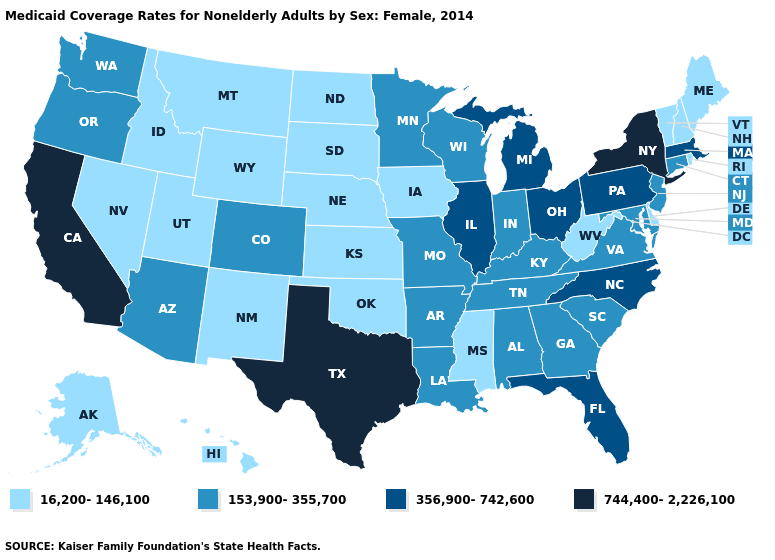What is the value of Texas?
Write a very short answer. 744,400-2,226,100. Among the states that border Maryland , which have the lowest value?
Answer briefly. Delaware, West Virginia. What is the value of Texas?
Concise answer only. 744,400-2,226,100. Does Michigan have the highest value in the MidWest?
Answer briefly. Yes. Does Virginia have the same value as Nevada?
Quick response, please. No. Does the map have missing data?
Concise answer only. No. Does Mississippi have a lower value than Ohio?
Answer briefly. Yes. Name the states that have a value in the range 16,200-146,100?
Be succinct. Alaska, Delaware, Hawaii, Idaho, Iowa, Kansas, Maine, Mississippi, Montana, Nebraska, Nevada, New Hampshire, New Mexico, North Dakota, Oklahoma, Rhode Island, South Dakota, Utah, Vermont, West Virginia, Wyoming. Name the states that have a value in the range 153,900-355,700?
Keep it brief. Alabama, Arizona, Arkansas, Colorado, Connecticut, Georgia, Indiana, Kentucky, Louisiana, Maryland, Minnesota, Missouri, New Jersey, Oregon, South Carolina, Tennessee, Virginia, Washington, Wisconsin. What is the lowest value in the South?
Concise answer only. 16,200-146,100. Does Missouri have the lowest value in the MidWest?
Keep it brief. No. What is the lowest value in the South?
Be succinct. 16,200-146,100. What is the value of Hawaii?
Be succinct. 16,200-146,100. Which states have the lowest value in the Northeast?
Write a very short answer. Maine, New Hampshire, Rhode Island, Vermont. What is the lowest value in states that border Wisconsin?
Give a very brief answer. 16,200-146,100. 